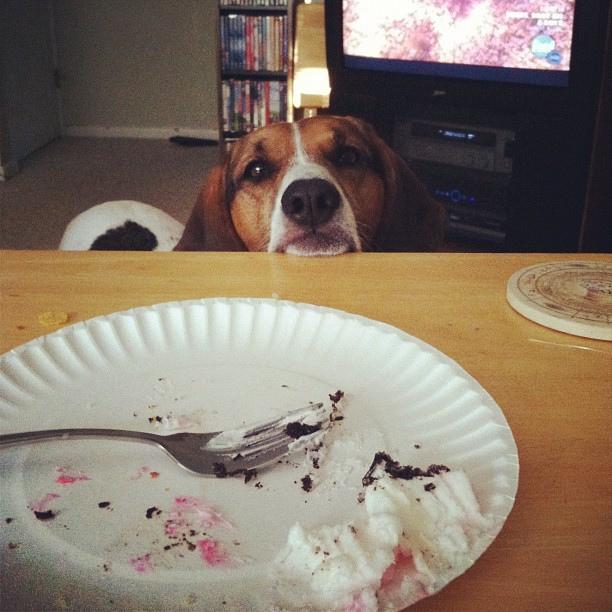What flavor was the cake that was eaten?
Keep it brief. Chocolate. What color is the table?
Keep it brief. Tan. Why are the dogs eyes green?
Concise answer only. Genetics. Does the dog want some cake?
Keep it brief. Yes. 